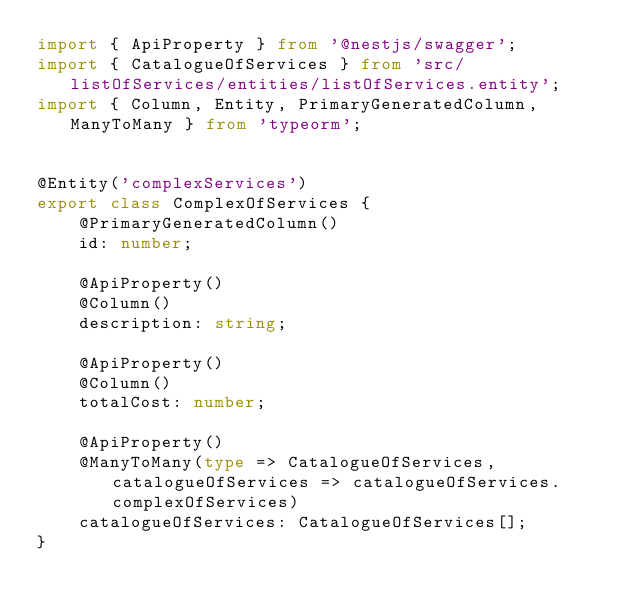Convert code to text. <code><loc_0><loc_0><loc_500><loc_500><_TypeScript_>import { ApiProperty } from '@nestjs/swagger';
import { CatalogueOfServices } from 'src/listOfServices/entities/listOfServices.entity';
import { Column, Entity, PrimaryGeneratedColumn, ManyToMany } from 'typeorm';


@Entity('complexServices')
export class ComplexOfServices {
    @PrimaryGeneratedColumn()
    id: number;

    @ApiProperty()
    @Column()
    description: string;

    @ApiProperty()
    @Column()
    totalCost: number;
    
    @ApiProperty()
    @ManyToMany(type => CatalogueOfServices, catalogueOfServices => catalogueOfServices.complexOfServices)
    catalogueOfServices: CatalogueOfServices[];
}</code> 